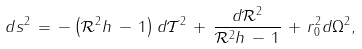Convert formula to latex. <formula><loc_0><loc_0><loc_500><loc_500>d s ^ { 2 } \, = \, - \left ( \mathcal { R } ^ { 2 } h \, - \, 1 \right ) d \mathcal { T } ^ { 2 } \, + \, \frac { d \mathcal { R } ^ { 2 } } { \mathcal { R } ^ { 2 } h \, - \, 1 } \, + \, r _ { 0 } ^ { 2 } d \Omega ^ { 2 } ,</formula> 